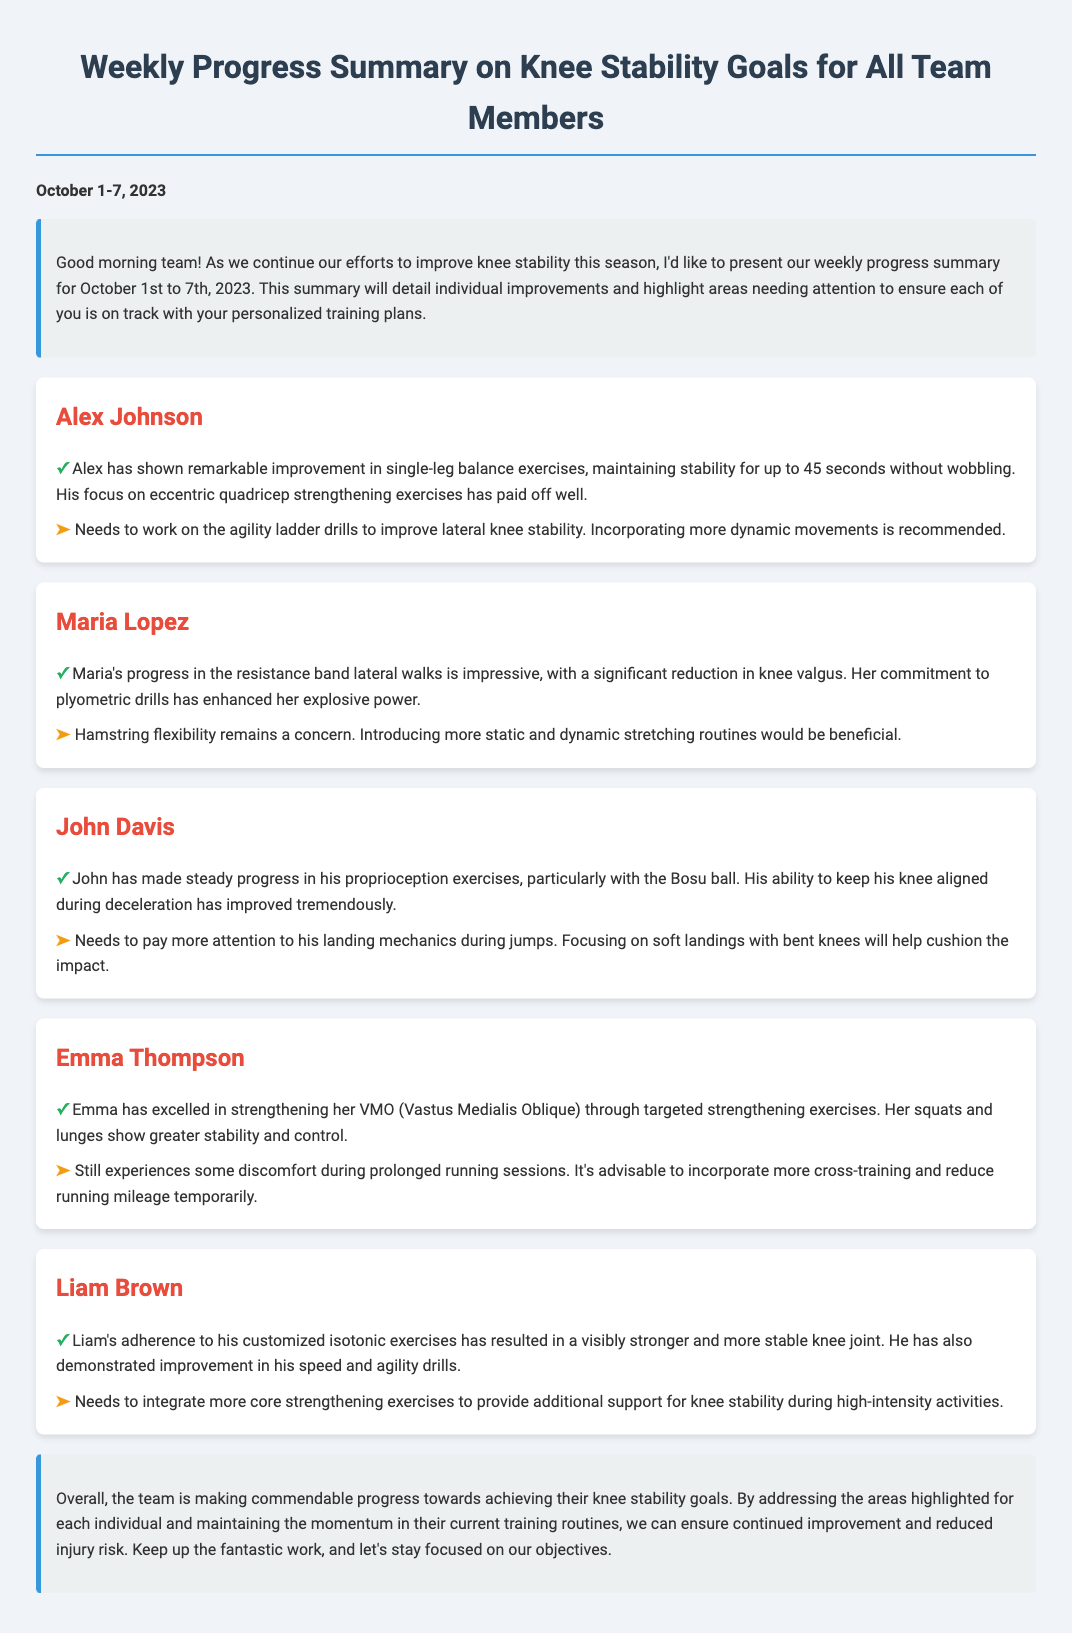What is the duration of Alex's single-leg balance exercise? Alex has maintained stability for up to 45 seconds during single-leg balance exercises, as mentioned in the summary.
Answer: 45 seconds Which team member shows improvement in lateral walks? The summary states that Maria's progress in the resistance band lateral walks is impressive, indicating improvement in that area.
Answer: Maria Lopez What specific muscle group is Emma strengthening? The document mentions that Emma has excelled in strengthening her VMO (Vastus Medialis Oblique) through targeted exercises, specifically identifying the muscle group.
Answer: VMO What aspect of John's training needs more attention? The summary highlights that John needs to pay more attention to his landing mechanics during jumps, indicating an area requiring improvement.
Answer: Landing mechanics Which exercise does Liam need to integrate more into his training? The document specifically states that Liam needs to integrate more core strengthening exercises, indicating the focus for enhancement.
Answer: Core strengthening exercises What type of stretching does Maria need to introduce? The summary mentions that introducing more static and dynamic stretching routines would be beneficial for Maria, highlighting the type of stretching recommended.
Answer: Static and dynamic stretching What equipment is mentioned in relation to John's proprioception exercises? The document states that John has made progress using the Bosu ball for proprioception exercises, identifying the equipment involved.
Answer: Bosu ball What is Emma's experience during prolonged running sessions? It is mentioned that Emma still experiences some discomfort during prolonged running sessions, reflecting her experience.
Answer: Discomfort What is a recommended activity for Emma to temporarily reduce? The summary advises that it's advisable to reduce running mileage temporarily, identifying an area for adjustment in her training.
Answer: Running mileage 